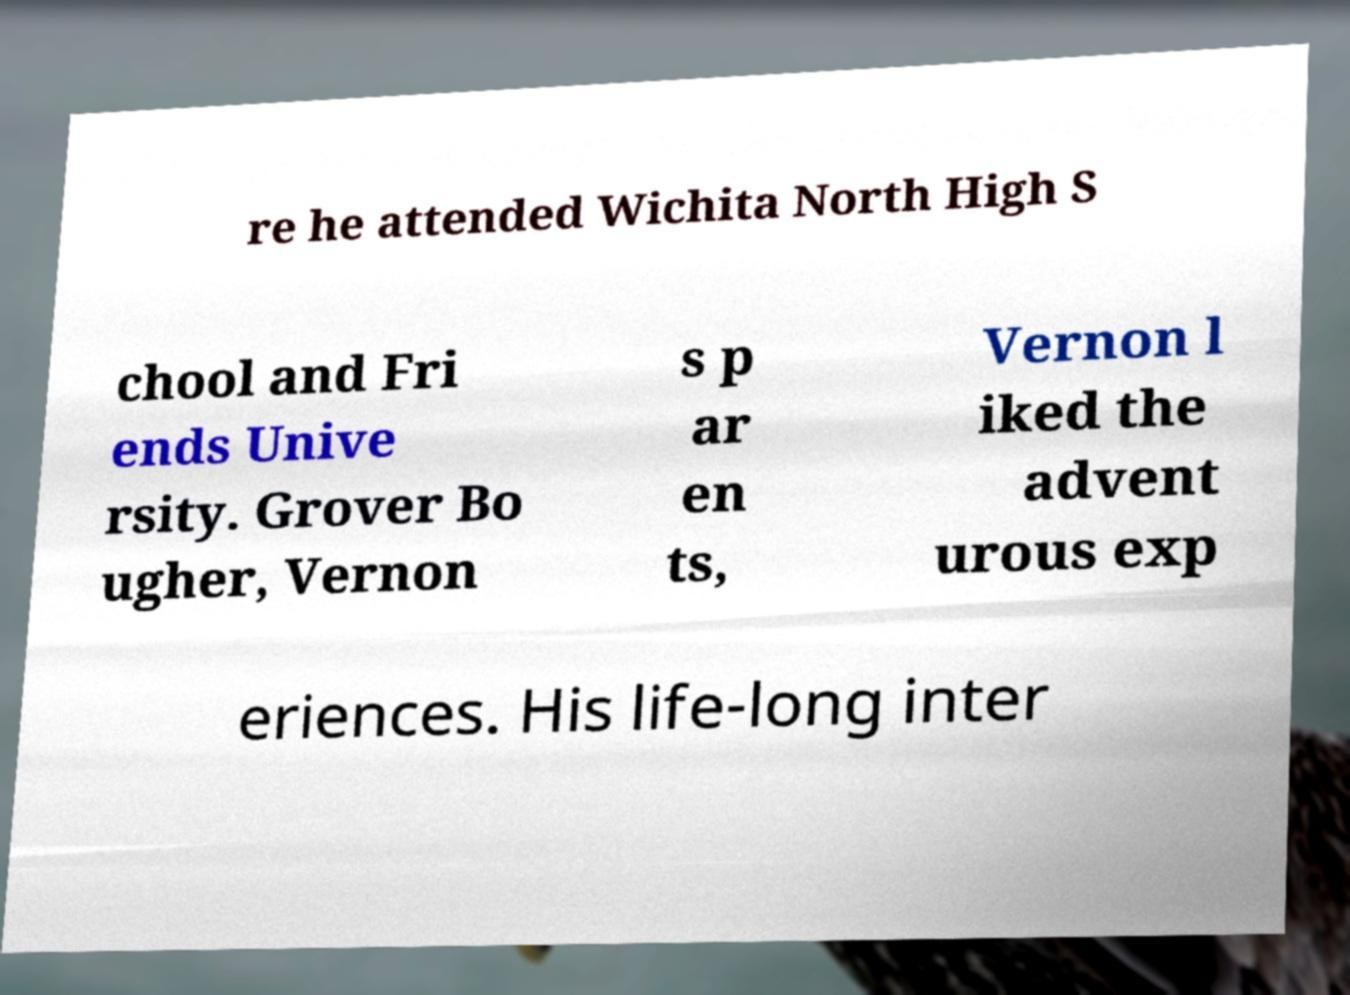Could you extract and type out the text from this image? re he attended Wichita North High S chool and Fri ends Unive rsity. Grover Bo ugher, Vernon s p ar en ts, Vernon l iked the advent urous exp eriences. His life-long inter 